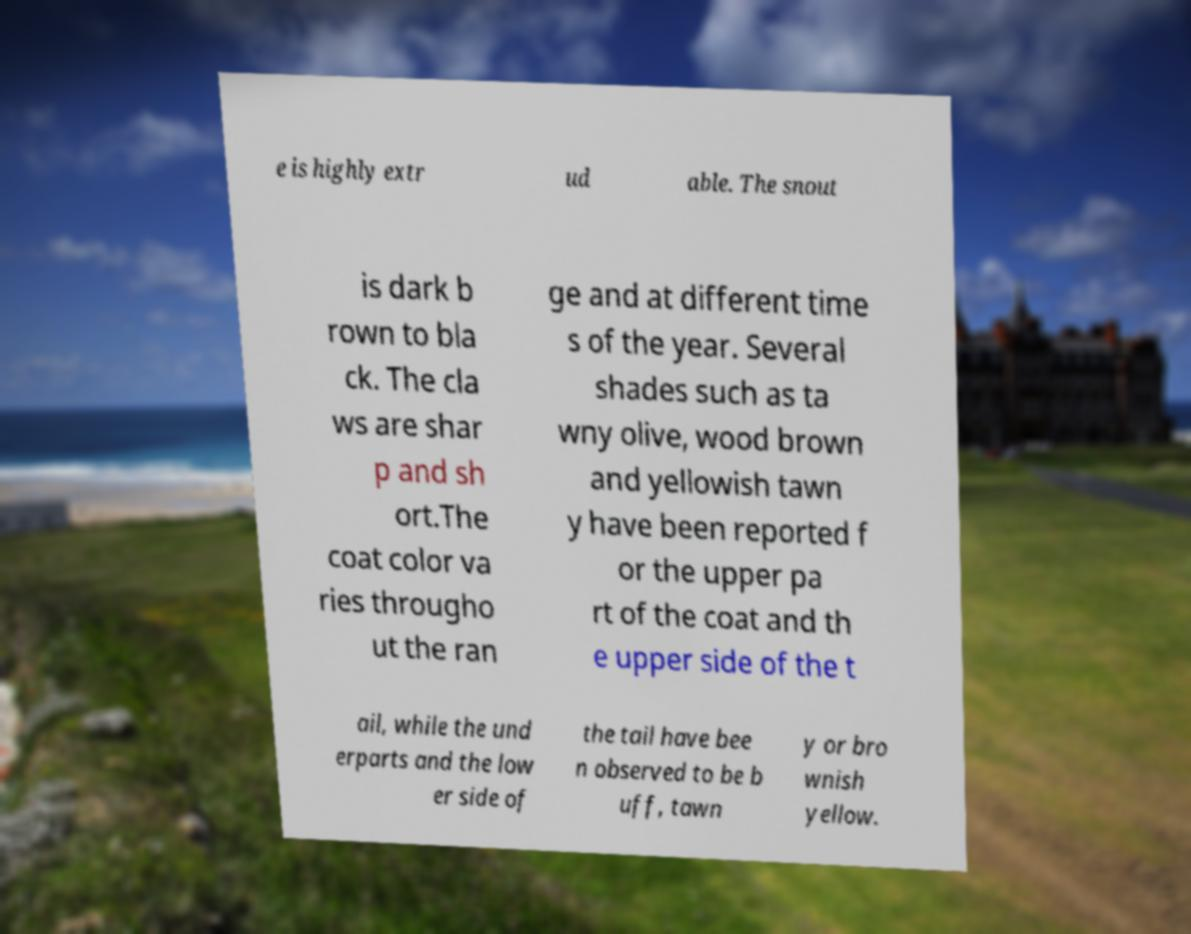Can you read and provide the text displayed in the image?This photo seems to have some interesting text. Can you extract and type it out for me? e is highly extr ud able. The snout is dark b rown to bla ck. The cla ws are shar p and sh ort.The coat color va ries througho ut the ran ge and at different time s of the year. Several shades such as ta wny olive, wood brown and yellowish tawn y have been reported f or the upper pa rt of the coat and th e upper side of the t ail, while the und erparts and the low er side of the tail have bee n observed to be b uff, tawn y or bro wnish yellow. 